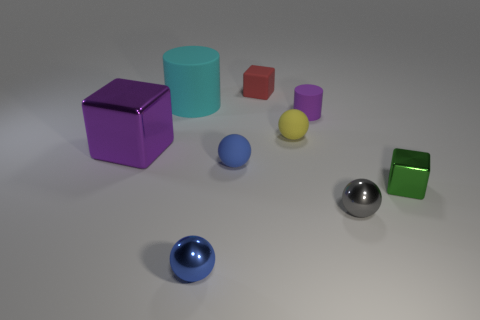Subtract all cylinders. How many objects are left? 7 Subtract all gray shiny balls. Subtract all big purple blocks. How many objects are left? 7 Add 5 blue rubber things. How many blue rubber things are left? 6 Add 6 large purple blocks. How many large purple blocks exist? 7 Subtract 0 gray cubes. How many objects are left? 9 